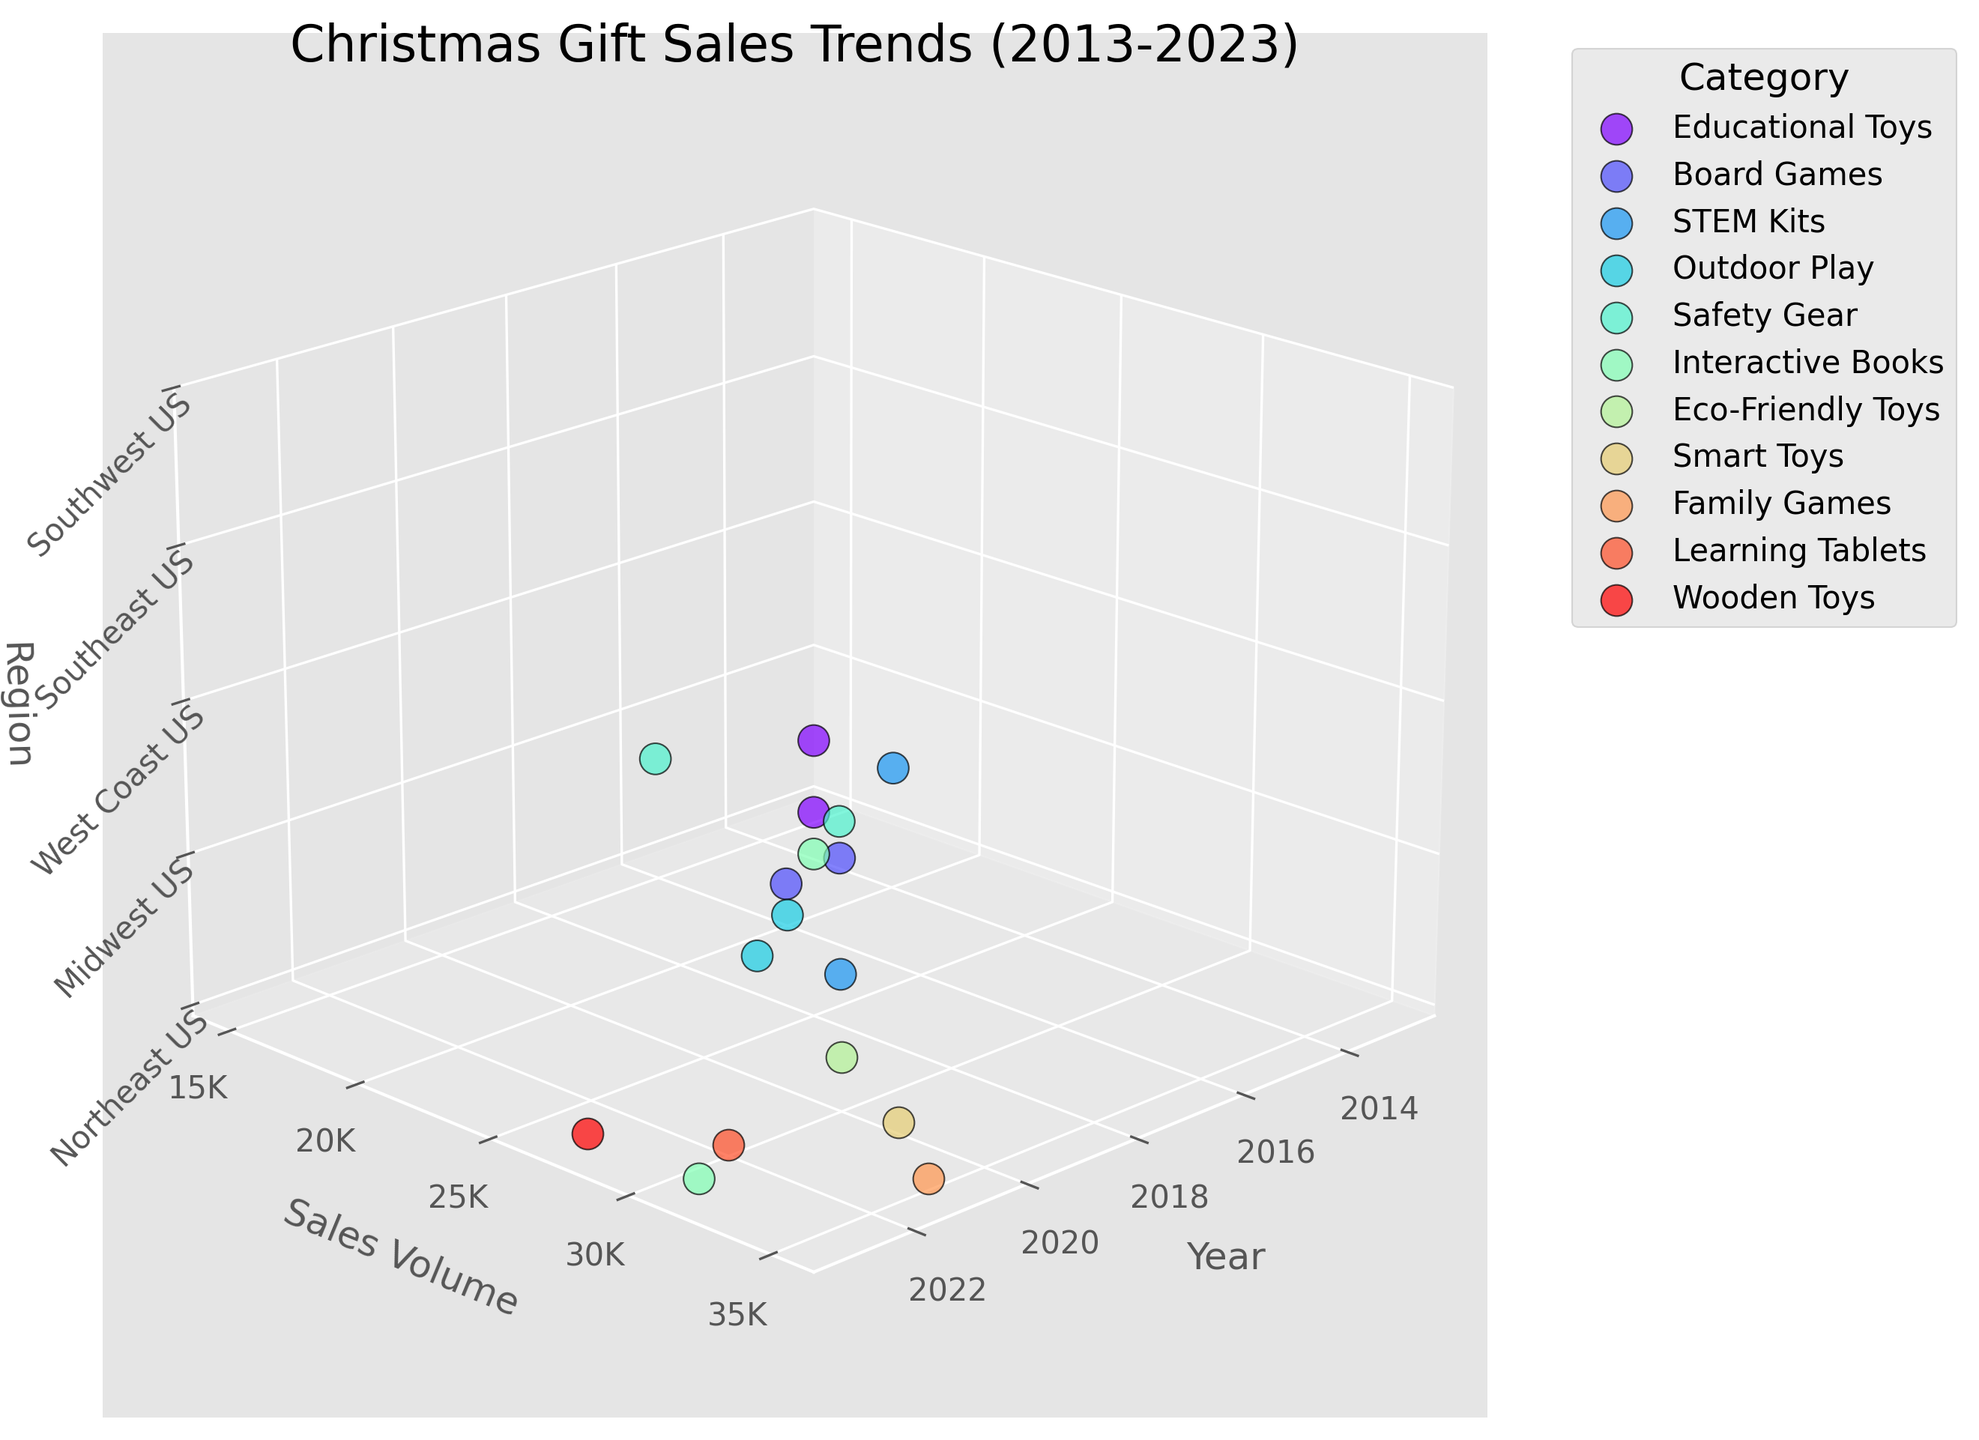What's the title of the figure? The title of the figure is usually found at the top of the plot. In this case, the title is "Christmas Gift Sales Trends (2013-2023)", which gives an overview of the data being presented.
Answer: Christmas Gift Sales Trends (2013-2023) What does the x-axis represent in the plot? The x-axis is labeled as "Year" which indicates that it represents the year in which the sales data was recorded.
Answer: Year Which category had the highest sales volume in 2021? Locate the scatter points for the year 2021 (x-axis = 2021). By comparing the sales volume (y-axis) of different categories, "Family Games" has the highest sales volume at 35000.
Answer: Family Games In which region did "Smart Toys" have the highest sales volume? Identify the category "Smart Toys". Then, find the corresponding highest sales volume along the y-axis and in which region (z-axis) it lies. "Smart Toys" had the highest sales volume on the West Coast US region.
Answer: West Coast US What is the sales volume range displayed on the y-axis? The y-axis ticks show the range of sales volume from 15000 to 40000, with ticks every 5000.
Answer: 15000 to 40000 How many categories are represented in the plot? Each category is represented by a different color and shown in the legend. Count the unique category labels in the legend. There are 10 categories.
Answer: 10 Which year saw the highest overall sales volume, and which category contributed to this peak? Look for the highest data point along the y-axis (Sales Volume). The year with the highest sales is 2021 with "Family Games" contributing to the peak with 35000 units.
Answer: 2021, Family Games Comparing 2019 to 2020, which category saw the largest increase in sales volume? Compare the sales volume for each category from 2019 to 2020. "Smart Toys" increased significantly from 26000 to 32000, giving it the largest increase of 6000 units.
Answer: Smart Toys In 2022, which region had the lowest sales volume and what was the category? For the year 2022 (x-axis), find the scatter point with the lowest sales volume (y-axis). The Southwest US had the lowest sales volume with "Learning Tablets" at 30000 units.
Answer: Southwest US, Learning Tablets How has the sales volume for "Educational Toys" changed from 2013 to 2023? Identify the sales volumes for "Educational Toys" in 2013 and then in 2023. Compare the figures to determine the change. The sales volume was 15000 in 2013 and 19000 in 2015, showing an increase.
Answer: Increased 